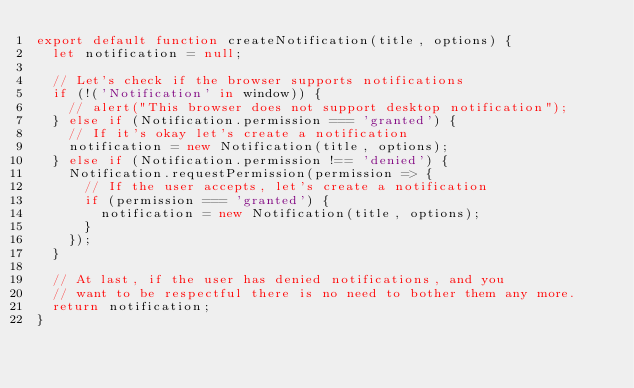<code> <loc_0><loc_0><loc_500><loc_500><_JavaScript_>export default function createNotification(title, options) {
  let notification = null;

  // Let's check if the browser supports notifications
  if (!('Notification' in window)) {
    // alert("This browser does not support desktop notification");
  } else if (Notification.permission === 'granted') {
    // If it's okay let's create a notification
    notification = new Notification(title, options);
  } else if (Notification.permission !== 'denied') {
    Notification.requestPermission(permission => {
      // If the user accepts, let's create a notification
      if (permission === 'granted') {
        notification = new Notification(title, options);
      }
    });
  }

  // At last, if the user has denied notifications, and you
  // want to be respectful there is no need to bother them any more.
  return notification;
}
</code> 